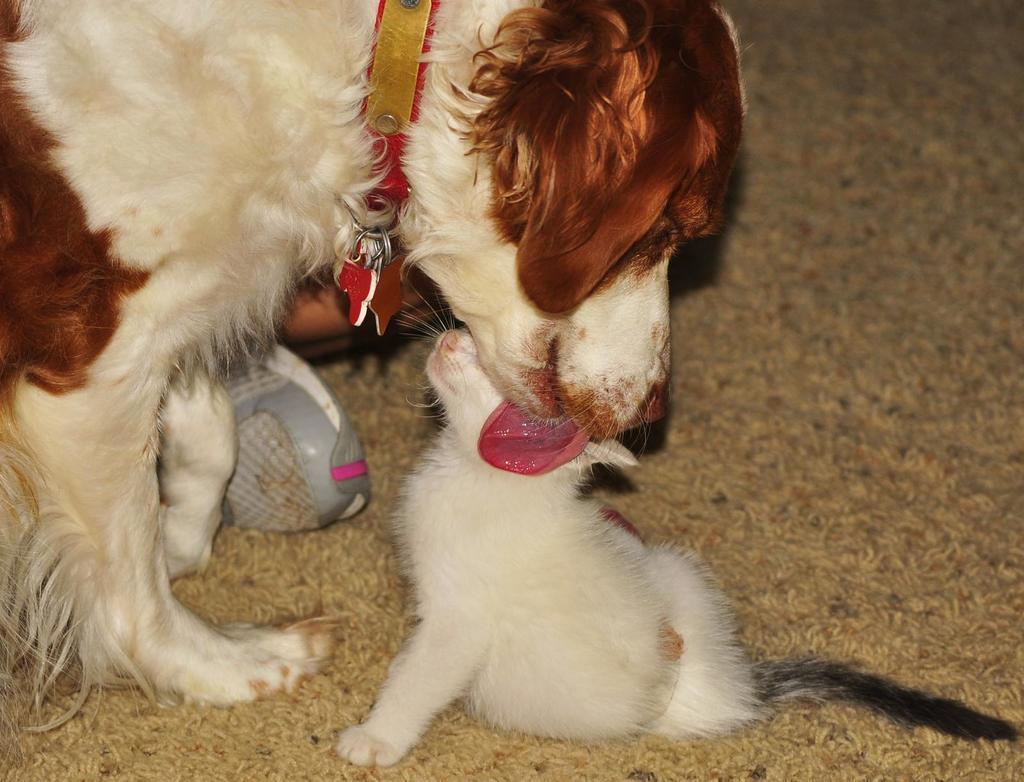How would you summarize this image in a sentence or two? In this picture I can see a dog and a cat on the carpet. 